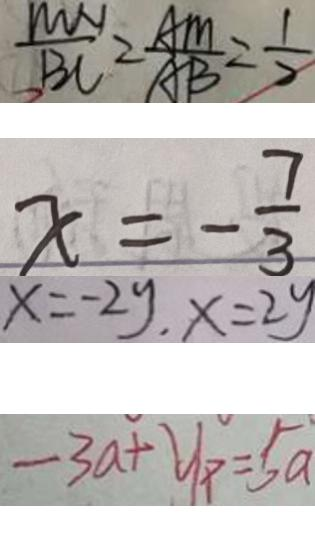Convert formula to latex. <formula><loc_0><loc_0><loc_500><loc_500>\frac { M N } { B C } = \frac { A M } { A B } = \frac { 1 } { 2 } 
 x = - \frac { 7 } { 3 } 
 x = - 2 y , x = 2 y 
 - 3 a + y _ { p } = 5 a</formula> 